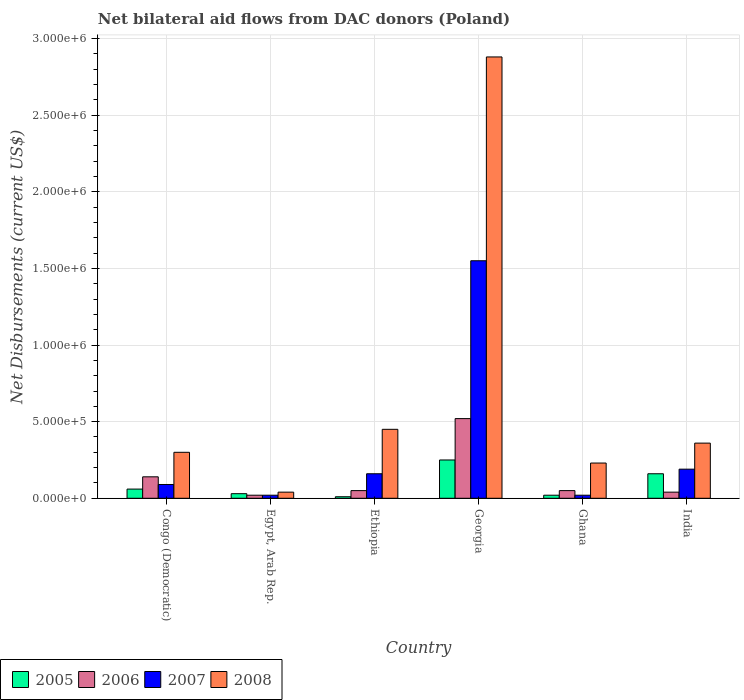How many bars are there on the 1st tick from the right?
Keep it short and to the point. 4. What is the label of the 2nd group of bars from the left?
Provide a short and direct response. Egypt, Arab Rep. In which country was the net bilateral aid flows in 2005 maximum?
Make the answer very short. Georgia. In which country was the net bilateral aid flows in 2006 minimum?
Offer a terse response. Egypt, Arab Rep. What is the total net bilateral aid flows in 2005 in the graph?
Your response must be concise. 5.30e+05. What is the difference between the net bilateral aid flows in 2005 in Ghana and that in India?
Your answer should be very brief. -1.40e+05. What is the average net bilateral aid flows in 2008 per country?
Provide a succinct answer. 7.10e+05. What is the difference between the net bilateral aid flows of/in 2006 and net bilateral aid flows of/in 2008 in Egypt, Arab Rep.?
Provide a short and direct response. -2.00e+04. In how many countries, is the net bilateral aid flows in 2008 greater than 1500000 US$?
Keep it short and to the point. 1. What is the ratio of the net bilateral aid flows in 2006 in Georgia to that in Ghana?
Your answer should be very brief. 10.4. Is the net bilateral aid flows in 2005 in Congo (Democratic) less than that in Ethiopia?
Make the answer very short. No. Is the difference between the net bilateral aid flows in 2006 in Congo (Democratic) and India greater than the difference between the net bilateral aid flows in 2008 in Congo (Democratic) and India?
Your answer should be very brief. Yes. What is the difference between the highest and the second highest net bilateral aid flows in 2007?
Keep it short and to the point. 1.39e+06. In how many countries, is the net bilateral aid flows in 2007 greater than the average net bilateral aid flows in 2007 taken over all countries?
Your response must be concise. 1. Is the sum of the net bilateral aid flows in 2007 in Egypt, Arab Rep. and Georgia greater than the maximum net bilateral aid flows in 2006 across all countries?
Keep it short and to the point. Yes. What does the 3rd bar from the right in Ghana represents?
Keep it short and to the point. 2006. How many bars are there?
Make the answer very short. 24. Are all the bars in the graph horizontal?
Your answer should be compact. No. Are the values on the major ticks of Y-axis written in scientific E-notation?
Give a very brief answer. Yes. How many legend labels are there?
Keep it short and to the point. 4. What is the title of the graph?
Your answer should be very brief. Net bilateral aid flows from DAC donors (Poland). What is the label or title of the X-axis?
Make the answer very short. Country. What is the label or title of the Y-axis?
Your answer should be compact. Net Disbursements (current US$). What is the Net Disbursements (current US$) of 2005 in Congo (Democratic)?
Ensure brevity in your answer.  6.00e+04. What is the Net Disbursements (current US$) of 2006 in Congo (Democratic)?
Your answer should be very brief. 1.40e+05. What is the Net Disbursements (current US$) in 2005 in Egypt, Arab Rep.?
Your answer should be compact. 3.00e+04. What is the Net Disbursements (current US$) of 2006 in Egypt, Arab Rep.?
Offer a terse response. 2.00e+04. What is the Net Disbursements (current US$) in 2008 in Egypt, Arab Rep.?
Ensure brevity in your answer.  4.00e+04. What is the Net Disbursements (current US$) in 2006 in Georgia?
Your answer should be compact. 5.20e+05. What is the Net Disbursements (current US$) of 2007 in Georgia?
Your response must be concise. 1.55e+06. What is the Net Disbursements (current US$) in 2008 in Georgia?
Offer a very short reply. 2.88e+06. What is the Net Disbursements (current US$) in 2007 in Ghana?
Make the answer very short. 2.00e+04. What is the Net Disbursements (current US$) of 2008 in Ghana?
Make the answer very short. 2.30e+05. What is the Net Disbursements (current US$) in 2005 in India?
Give a very brief answer. 1.60e+05. What is the Net Disbursements (current US$) in 2007 in India?
Provide a succinct answer. 1.90e+05. What is the Net Disbursements (current US$) of 2008 in India?
Provide a short and direct response. 3.60e+05. Across all countries, what is the maximum Net Disbursements (current US$) in 2005?
Make the answer very short. 2.50e+05. Across all countries, what is the maximum Net Disbursements (current US$) of 2006?
Your answer should be compact. 5.20e+05. Across all countries, what is the maximum Net Disbursements (current US$) in 2007?
Ensure brevity in your answer.  1.55e+06. Across all countries, what is the maximum Net Disbursements (current US$) in 2008?
Your answer should be very brief. 2.88e+06. Across all countries, what is the minimum Net Disbursements (current US$) in 2008?
Your response must be concise. 4.00e+04. What is the total Net Disbursements (current US$) of 2005 in the graph?
Provide a succinct answer. 5.30e+05. What is the total Net Disbursements (current US$) of 2006 in the graph?
Your answer should be very brief. 8.20e+05. What is the total Net Disbursements (current US$) of 2007 in the graph?
Your answer should be compact. 2.03e+06. What is the total Net Disbursements (current US$) of 2008 in the graph?
Make the answer very short. 4.26e+06. What is the difference between the Net Disbursements (current US$) in 2005 in Congo (Democratic) and that in Egypt, Arab Rep.?
Offer a terse response. 3.00e+04. What is the difference between the Net Disbursements (current US$) of 2007 in Congo (Democratic) and that in Ethiopia?
Offer a terse response. -7.00e+04. What is the difference between the Net Disbursements (current US$) in 2008 in Congo (Democratic) and that in Ethiopia?
Offer a very short reply. -1.50e+05. What is the difference between the Net Disbursements (current US$) of 2006 in Congo (Democratic) and that in Georgia?
Your answer should be compact. -3.80e+05. What is the difference between the Net Disbursements (current US$) of 2007 in Congo (Democratic) and that in Georgia?
Ensure brevity in your answer.  -1.46e+06. What is the difference between the Net Disbursements (current US$) in 2008 in Congo (Democratic) and that in Georgia?
Give a very brief answer. -2.58e+06. What is the difference between the Net Disbursements (current US$) in 2005 in Congo (Democratic) and that in Ghana?
Your answer should be very brief. 4.00e+04. What is the difference between the Net Disbursements (current US$) in 2006 in Congo (Democratic) and that in Ghana?
Ensure brevity in your answer.  9.00e+04. What is the difference between the Net Disbursements (current US$) in 2005 in Congo (Democratic) and that in India?
Provide a short and direct response. -1.00e+05. What is the difference between the Net Disbursements (current US$) in 2006 in Congo (Democratic) and that in India?
Your answer should be very brief. 1.00e+05. What is the difference between the Net Disbursements (current US$) of 2008 in Egypt, Arab Rep. and that in Ethiopia?
Provide a succinct answer. -4.10e+05. What is the difference between the Net Disbursements (current US$) in 2006 in Egypt, Arab Rep. and that in Georgia?
Make the answer very short. -5.00e+05. What is the difference between the Net Disbursements (current US$) of 2007 in Egypt, Arab Rep. and that in Georgia?
Your answer should be compact. -1.53e+06. What is the difference between the Net Disbursements (current US$) in 2008 in Egypt, Arab Rep. and that in Georgia?
Give a very brief answer. -2.84e+06. What is the difference between the Net Disbursements (current US$) in 2006 in Egypt, Arab Rep. and that in Ghana?
Provide a short and direct response. -3.00e+04. What is the difference between the Net Disbursements (current US$) in 2007 in Egypt, Arab Rep. and that in Ghana?
Give a very brief answer. 0. What is the difference between the Net Disbursements (current US$) in 2008 in Egypt, Arab Rep. and that in Ghana?
Offer a very short reply. -1.90e+05. What is the difference between the Net Disbursements (current US$) of 2007 in Egypt, Arab Rep. and that in India?
Your response must be concise. -1.70e+05. What is the difference between the Net Disbursements (current US$) in 2008 in Egypt, Arab Rep. and that in India?
Your answer should be very brief. -3.20e+05. What is the difference between the Net Disbursements (current US$) of 2006 in Ethiopia and that in Georgia?
Give a very brief answer. -4.70e+05. What is the difference between the Net Disbursements (current US$) in 2007 in Ethiopia and that in Georgia?
Ensure brevity in your answer.  -1.39e+06. What is the difference between the Net Disbursements (current US$) in 2008 in Ethiopia and that in Georgia?
Provide a short and direct response. -2.43e+06. What is the difference between the Net Disbursements (current US$) of 2005 in Ethiopia and that in Ghana?
Your response must be concise. -10000. What is the difference between the Net Disbursements (current US$) of 2005 in Ethiopia and that in India?
Your answer should be compact. -1.50e+05. What is the difference between the Net Disbursements (current US$) of 2006 in Ethiopia and that in India?
Offer a very short reply. 10000. What is the difference between the Net Disbursements (current US$) of 2008 in Ethiopia and that in India?
Make the answer very short. 9.00e+04. What is the difference between the Net Disbursements (current US$) of 2005 in Georgia and that in Ghana?
Provide a short and direct response. 2.30e+05. What is the difference between the Net Disbursements (current US$) of 2007 in Georgia and that in Ghana?
Provide a succinct answer. 1.53e+06. What is the difference between the Net Disbursements (current US$) of 2008 in Georgia and that in Ghana?
Give a very brief answer. 2.65e+06. What is the difference between the Net Disbursements (current US$) in 2006 in Georgia and that in India?
Keep it short and to the point. 4.80e+05. What is the difference between the Net Disbursements (current US$) in 2007 in Georgia and that in India?
Offer a terse response. 1.36e+06. What is the difference between the Net Disbursements (current US$) of 2008 in Georgia and that in India?
Give a very brief answer. 2.52e+06. What is the difference between the Net Disbursements (current US$) of 2005 in Congo (Democratic) and the Net Disbursements (current US$) of 2007 in Egypt, Arab Rep.?
Your answer should be very brief. 4.00e+04. What is the difference between the Net Disbursements (current US$) in 2005 in Congo (Democratic) and the Net Disbursements (current US$) in 2008 in Egypt, Arab Rep.?
Keep it short and to the point. 2.00e+04. What is the difference between the Net Disbursements (current US$) of 2006 in Congo (Democratic) and the Net Disbursements (current US$) of 2007 in Egypt, Arab Rep.?
Keep it short and to the point. 1.20e+05. What is the difference between the Net Disbursements (current US$) in 2006 in Congo (Democratic) and the Net Disbursements (current US$) in 2008 in Egypt, Arab Rep.?
Your answer should be compact. 1.00e+05. What is the difference between the Net Disbursements (current US$) in 2007 in Congo (Democratic) and the Net Disbursements (current US$) in 2008 in Egypt, Arab Rep.?
Your response must be concise. 5.00e+04. What is the difference between the Net Disbursements (current US$) of 2005 in Congo (Democratic) and the Net Disbursements (current US$) of 2006 in Ethiopia?
Offer a very short reply. 10000. What is the difference between the Net Disbursements (current US$) in 2005 in Congo (Democratic) and the Net Disbursements (current US$) in 2007 in Ethiopia?
Your answer should be compact. -1.00e+05. What is the difference between the Net Disbursements (current US$) of 2005 in Congo (Democratic) and the Net Disbursements (current US$) of 2008 in Ethiopia?
Your answer should be compact. -3.90e+05. What is the difference between the Net Disbursements (current US$) of 2006 in Congo (Democratic) and the Net Disbursements (current US$) of 2008 in Ethiopia?
Provide a short and direct response. -3.10e+05. What is the difference between the Net Disbursements (current US$) in 2007 in Congo (Democratic) and the Net Disbursements (current US$) in 2008 in Ethiopia?
Keep it short and to the point. -3.60e+05. What is the difference between the Net Disbursements (current US$) of 2005 in Congo (Democratic) and the Net Disbursements (current US$) of 2006 in Georgia?
Provide a short and direct response. -4.60e+05. What is the difference between the Net Disbursements (current US$) of 2005 in Congo (Democratic) and the Net Disbursements (current US$) of 2007 in Georgia?
Give a very brief answer. -1.49e+06. What is the difference between the Net Disbursements (current US$) in 2005 in Congo (Democratic) and the Net Disbursements (current US$) in 2008 in Georgia?
Provide a short and direct response. -2.82e+06. What is the difference between the Net Disbursements (current US$) in 2006 in Congo (Democratic) and the Net Disbursements (current US$) in 2007 in Georgia?
Your answer should be compact. -1.41e+06. What is the difference between the Net Disbursements (current US$) in 2006 in Congo (Democratic) and the Net Disbursements (current US$) in 2008 in Georgia?
Make the answer very short. -2.74e+06. What is the difference between the Net Disbursements (current US$) in 2007 in Congo (Democratic) and the Net Disbursements (current US$) in 2008 in Georgia?
Offer a very short reply. -2.79e+06. What is the difference between the Net Disbursements (current US$) in 2006 in Congo (Democratic) and the Net Disbursements (current US$) in 2008 in Ghana?
Keep it short and to the point. -9.00e+04. What is the difference between the Net Disbursements (current US$) in 2007 in Congo (Democratic) and the Net Disbursements (current US$) in 2008 in Ghana?
Ensure brevity in your answer.  -1.40e+05. What is the difference between the Net Disbursements (current US$) of 2005 in Congo (Democratic) and the Net Disbursements (current US$) of 2006 in India?
Provide a succinct answer. 2.00e+04. What is the difference between the Net Disbursements (current US$) in 2005 in Congo (Democratic) and the Net Disbursements (current US$) in 2008 in India?
Provide a succinct answer. -3.00e+05. What is the difference between the Net Disbursements (current US$) in 2006 in Congo (Democratic) and the Net Disbursements (current US$) in 2007 in India?
Offer a terse response. -5.00e+04. What is the difference between the Net Disbursements (current US$) of 2006 in Congo (Democratic) and the Net Disbursements (current US$) of 2008 in India?
Make the answer very short. -2.20e+05. What is the difference between the Net Disbursements (current US$) in 2005 in Egypt, Arab Rep. and the Net Disbursements (current US$) in 2008 in Ethiopia?
Ensure brevity in your answer.  -4.20e+05. What is the difference between the Net Disbursements (current US$) in 2006 in Egypt, Arab Rep. and the Net Disbursements (current US$) in 2008 in Ethiopia?
Offer a very short reply. -4.30e+05. What is the difference between the Net Disbursements (current US$) of 2007 in Egypt, Arab Rep. and the Net Disbursements (current US$) of 2008 in Ethiopia?
Provide a succinct answer. -4.30e+05. What is the difference between the Net Disbursements (current US$) in 2005 in Egypt, Arab Rep. and the Net Disbursements (current US$) in 2006 in Georgia?
Keep it short and to the point. -4.90e+05. What is the difference between the Net Disbursements (current US$) in 2005 in Egypt, Arab Rep. and the Net Disbursements (current US$) in 2007 in Georgia?
Provide a short and direct response. -1.52e+06. What is the difference between the Net Disbursements (current US$) in 2005 in Egypt, Arab Rep. and the Net Disbursements (current US$) in 2008 in Georgia?
Make the answer very short. -2.85e+06. What is the difference between the Net Disbursements (current US$) in 2006 in Egypt, Arab Rep. and the Net Disbursements (current US$) in 2007 in Georgia?
Offer a very short reply. -1.53e+06. What is the difference between the Net Disbursements (current US$) of 2006 in Egypt, Arab Rep. and the Net Disbursements (current US$) of 2008 in Georgia?
Offer a terse response. -2.86e+06. What is the difference between the Net Disbursements (current US$) in 2007 in Egypt, Arab Rep. and the Net Disbursements (current US$) in 2008 in Georgia?
Ensure brevity in your answer.  -2.86e+06. What is the difference between the Net Disbursements (current US$) of 2005 in Egypt, Arab Rep. and the Net Disbursements (current US$) of 2006 in Ghana?
Give a very brief answer. -2.00e+04. What is the difference between the Net Disbursements (current US$) in 2006 in Egypt, Arab Rep. and the Net Disbursements (current US$) in 2008 in Ghana?
Offer a terse response. -2.10e+05. What is the difference between the Net Disbursements (current US$) in 2005 in Egypt, Arab Rep. and the Net Disbursements (current US$) in 2006 in India?
Offer a very short reply. -10000. What is the difference between the Net Disbursements (current US$) in 2005 in Egypt, Arab Rep. and the Net Disbursements (current US$) in 2008 in India?
Your response must be concise. -3.30e+05. What is the difference between the Net Disbursements (current US$) in 2006 in Egypt, Arab Rep. and the Net Disbursements (current US$) in 2007 in India?
Keep it short and to the point. -1.70e+05. What is the difference between the Net Disbursements (current US$) of 2006 in Egypt, Arab Rep. and the Net Disbursements (current US$) of 2008 in India?
Provide a short and direct response. -3.40e+05. What is the difference between the Net Disbursements (current US$) of 2007 in Egypt, Arab Rep. and the Net Disbursements (current US$) of 2008 in India?
Keep it short and to the point. -3.40e+05. What is the difference between the Net Disbursements (current US$) in 2005 in Ethiopia and the Net Disbursements (current US$) in 2006 in Georgia?
Your response must be concise. -5.10e+05. What is the difference between the Net Disbursements (current US$) of 2005 in Ethiopia and the Net Disbursements (current US$) of 2007 in Georgia?
Your answer should be very brief. -1.54e+06. What is the difference between the Net Disbursements (current US$) in 2005 in Ethiopia and the Net Disbursements (current US$) in 2008 in Georgia?
Your response must be concise. -2.87e+06. What is the difference between the Net Disbursements (current US$) in 2006 in Ethiopia and the Net Disbursements (current US$) in 2007 in Georgia?
Offer a terse response. -1.50e+06. What is the difference between the Net Disbursements (current US$) in 2006 in Ethiopia and the Net Disbursements (current US$) in 2008 in Georgia?
Provide a succinct answer. -2.83e+06. What is the difference between the Net Disbursements (current US$) of 2007 in Ethiopia and the Net Disbursements (current US$) of 2008 in Georgia?
Make the answer very short. -2.72e+06. What is the difference between the Net Disbursements (current US$) in 2005 in Ethiopia and the Net Disbursements (current US$) in 2008 in Ghana?
Offer a terse response. -2.20e+05. What is the difference between the Net Disbursements (current US$) in 2006 in Ethiopia and the Net Disbursements (current US$) in 2007 in Ghana?
Give a very brief answer. 3.00e+04. What is the difference between the Net Disbursements (current US$) of 2006 in Ethiopia and the Net Disbursements (current US$) of 2008 in Ghana?
Offer a terse response. -1.80e+05. What is the difference between the Net Disbursements (current US$) of 2007 in Ethiopia and the Net Disbursements (current US$) of 2008 in Ghana?
Your answer should be compact. -7.00e+04. What is the difference between the Net Disbursements (current US$) in 2005 in Ethiopia and the Net Disbursements (current US$) in 2006 in India?
Your answer should be very brief. -3.00e+04. What is the difference between the Net Disbursements (current US$) in 2005 in Ethiopia and the Net Disbursements (current US$) in 2008 in India?
Keep it short and to the point. -3.50e+05. What is the difference between the Net Disbursements (current US$) of 2006 in Ethiopia and the Net Disbursements (current US$) of 2008 in India?
Your response must be concise. -3.10e+05. What is the difference between the Net Disbursements (current US$) of 2005 in Georgia and the Net Disbursements (current US$) of 2007 in Ghana?
Your response must be concise. 2.30e+05. What is the difference between the Net Disbursements (current US$) of 2006 in Georgia and the Net Disbursements (current US$) of 2007 in Ghana?
Your response must be concise. 5.00e+05. What is the difference between the Net Disbursements (current US$) of 2006 in Georgia and the Net Disbursements (current US$) of 2008 in Ghana?
Your answer should be very brief. 2.90e+05. What is the difference between the Net Disbursements (current US$) in 2007 in Georgia and the Net Disbursements (current US$) in 2008 in Ghana?
Provide a short and direct response. 1.32e+06. What is the difference between the Net Disbursements (current US$) of 2005 in Georgia and the Net Disbursements (current US$) of 2006 in India?
Keep it short and to the point. 2.10e+05. What is the difference between the Net Disbursements (current US$) of 2005 in Georgia and the Net Disbursements (current US$) of 2007 in India?
Your response must be concise. 6.00e+04. What is the difference between the Net Disbursements (current US$) of 2006 in Georgia and the Net Disbursements (current US$) of 2008 in India?
Your answer should be compact. 1.60e+05. What is the difference between the Net Disbursements (current US$) of 2007 in Georgia and the Net Disbursements (current US$) of 2008 in India?
Provide a short and direct response. 1.19e+06. What is the difference between the Net Disbursements (current US$) of 2005 in Ghana and the Net Disbursements (current US$) of 2006 in India?
Provide a succinct answer. -2.00e+04. What is the difference between the Net Disbursements (current US$) of 2005 in Ghana and the Net Disbursements (current US$) of 2007 in India?
Offer a terse response. -1.70e+05. What is the difference between the Net Disbursements (current US$) in 2006 in Ghana and the Net Disbursements (current US$) in 2007 in India?
Provide a succinct answer. -1.40e+05. What is the difference between the Net Disbursements (current US$) in 2006 in Ghana and the Net Disbursements (current US$) in 2008 in India?
Your answer should be very brief. -3.10e+05. What is the average Net Disbursements (current US$) in 2005 per country?
Make the answer very short. 8.83e+04. What is the average Net Disbursements (current US$) of 2006 per country?
Keep it short and to the point. 1.37e+05. What is the average Net Disbursements (current US$) in 2007 per country?
Your response must be concise. 3.38e+05. What is the average Net Disbursements (current US$) in 2008 per country?
Offer a terse response. 7.10e+05. What is the difference between the Net Disbursements (current US$) of 2005 and Net Disbursements (current US$) of 2006 in Congo (Democratic)?
Your answer should be very brief. -8.00e+04. What is the difference between the Net Disbursements (current US$) in 2005 and Net Disbursements (current US$) in 2007 in Congo (Democratic)?
Make the answer very short. -3.00e+04. What is the difference between the Net Disbursements (current US$) in 2006 and Net Disbursements (current US$) in 2007 in Congo (Democratic)?
Your answer should be compact. 5.00e+04. What is the difference between the Net Disbursements (current US$) in 2005 and Net Disbursements (current US$) in 2007 in Egypt, Arab Rep.?
Keep it short and to the point. 10000. What is the difference between the Net Disbursements (current US$) in 2007 and Net Disbursements (current US$) in 2008 in Egypt, Arab Rep.?
Your response must be concise. -2.00e+04. What is the difference between the Net Disbursements (current US$) of 2005 and Net Disbursements (current US$) of 2006 in Ethiopia?
Provide a short and direct response. -4.00e+04. What is the difference between the Net Disbursements (current US$) of 2005 and Net Disbursements (current US$) of 2007 in Ethiopia?
Offer a terse response. -1.50e+05. What is the difference between the Net Disbursements (current US$) in 2005 and Net Disbursements (current US$) in 2008 in Ethiopia?
Keep it short and to the point. -4.40e+05. What is the difference between the Net Disbursements (current US$) in 2006 and Net Disbursements (current US$) in 2007 in Ethiopia?
Provide a succinct answer. -1.10e+05. What is the difference between the Net Disbursements (current US$) of 2006 and Net Disbursements (current US$) of 2008 in Ethiopia?
Provide a short and direct response. -4.00e+05. What is the difference between the Net Disbursements (current US$) of 2005 and Net Disbursements (current US$) of 2007 in Georgia?
Offer a very short reply. -1.30e+06. What is the difference between the Net Disbursements (current US$) in 2005 and Net Disbursements (current US$) in 2008 in Georgia?
Make the answer very short. -2.63e+06. What is the difference between the Net Disbursements (current US$) in 2006 and Net Disbursements (current US$) in 2007 in Georgia?
Ensure brevity in your answer.  -1.03e+06. What is the difference between the Net Disbursements (current US$) of 2006 and Net Disbursements (current US$) of 2008 in Georgia?
Your answer should be compact. -2.36e+06. What is the difference between the Net Disbursements (current US$) of 2007 and Net Disbursements (current US$) of 2008 in Georgia?
Your answer should be very brief. -1.33e+06. What is the difference between the Net Disbursements (current US$) in 2005 and Net Disbursements (current US$) in 2008 in Ghana?
Provide a short and direct response. -2.10e+05. What is the difference between the Net Disbursements (current US$) in 2007 and Net Disbursements (current US$) in 2008 in Ghana?
Offer a terse response. -2.10e+05. What is the difference between the Net Disbursements (current US$) in 2005 and Net Disbursements (current US$) in 2006 in India?
Provide a short and direct response. 1.20e+05. What is the difference between the Net Disbursements (current US$) of 2006 and Net Disbursements (current US$) of 2008 in India?
Provide a succinct answer. -3.20e+05. What is the ratio of the Net Disbursements (current US$) of 2005 in Congo (Democratic) to that in Ethiopia?
Give a very brief answer. 6. What is the ratio of the Net Disbursements (current US$) of 2007 in Congo (Democratic) to that in Ethiopia?
Offer a very short reply. 0.56. What is the ratio of the Net Disbursements (current US$) in 2005 in Congo (Democratic) to that in Georgia?
Give a very brief answer. 0.24. What is the ratio of the Net Disbursements (current US$) in 2006 in Congo (Democratic) to that in Georgia?
Offer a terse response. 0.27. What is the ratio of the Net Disbursements (current US$) in 2007 in Congo (Democratic) to that in Georgia?
Your response must be concise. 0.06. What is the ratio of the Net Disbursements (current US$) in 2008 in Congo (Democratic) to that in Georgia?
Your answer should be very brief. 0.1. What is the ratio of the Net Disbursements (current US$) of 2007 in Congo (Democratic) to that in Ghana?
Offer a terse response. 4.5. What is the ratio of the Net Disbursements (current US$) of 2008 in Congo (Democratic) to that in Ghana?
Ensure brevity in your answer.  1.3. What is the ratio of the Net Disbursements (current US$) of 2005 in Congo (Democratic) to that in India?
Keep it short and to the point. 0.38. What is the ratio of the Net Disbursements (current US$) in 2006 in Congo (Democratic) to that in India?
Give a very brief answer. 3.5. What is the ratio of the Net Disbursements (current US$) of 2007 in Congo (Democratic) to that in India?
Your response must be concise. 0.47. What is the ratio of the Net Disbursements (current US$) in 2005 in Egypt, Arab Rep. to that in Ethiopia?
Make the answer very short. 3. What is the ratio of the Net Disbursements (current US$) of 2007 in Egypt, Arab Rep. to that in Ethiopia?
Give a very brief answer. 0.12. What is the ratio of the Net Disbursements (current US$) in 2008 in Egypt, Arab Rep. to that in Ethiopia?
Keep it short and to the point. 0.09. What is the ratio of the Net Disbursements (current US$) of 2005 in Egypt, Arab Rep. to that in Georgia?
Make the answer very short. 0.12. What is the ratio of the Net Disbursements (current US$) of 2006 in Egypt, Arab Rep. to that in Georgia?
Your answer should be very brief. 0.04. What is the ratio of the Net Disbursements (current US$) in 2007 in Egypt, Arab Rep. to that in Georgia?
Make the answer very short. 0.01. What is the ratio of the Net Disbursements (current US$) of 2008 in Egypt, Arab Rep. to that in Georgia?
Offer a terse response. 0.01. What is the ratio of the Net Disbursements (current US$) in 2005 in Egypt, Arab Rep. to that in Ghana?
Offer a very short reply. 1.5. What is the ratio of the Net Disbursements (current US$) of 2007 in Egypt, Arab Rep. to that in Ghana?
Your answer should be compact. 1. What is the ratio of the Net Disbursements (current US$) of 2008 in Egypt, Arab Rep. to that in Ghana?
Your response must be concise. 0.17. What is the ratio of the Net Disbursements (current US$) of 2005 in Egypt, Arab Rep. to that in India?
Your answer should be very brief. 0.19. What is the ratio of the Net Disbursements (current US$) in 2006 in Egypt, Arab Rep. to that in India?
Your response must be concise. 0.5. What is the ratio of the Net Disbursements (current US$) in 2007 in Egypt, Arab Rep. to that in India?
Offer a terse response. 0.11. What is the ratio of the Net Disbursements (current US$) in 2008 in Egypt, Arab Rep. to that in India?
Your response must be concise. 0.11. What is the ratio of the Net Disbursements (current US$) in 2005 in Ethiopia to that in Georgia?
Ensure brevity in your answer.  0.04. What is the ratio of the Net Disbursements (current US$) in 2006 in Ethiopia to that in Georgia?
Your response must be concise. 0.1. What is the ratio of the Net Disbursements (current US$) in 2007 in Ethiopia to that in Georgia?
Your answer should be very brief. 0.1. What is the ratio of the Net Disbursements (current US$) of 2008 in Ethiopia to that in Georgia?
Your response must be concise. 0.16. What is the ratio of the Net Disbursements (current US$) in 2005 in Ethiopia to that in Ghana?
Offer a terse response. 0.5. What is the ratio of the Net Disbursements (current US$) of 2007 in Ethiopia to that in Ghana?
Ensure brevity in your answer.  8. What is the ratio of the Net Disbursements (current US$) of 2008 in Ethiopia to that in Ghana?
Provide a succinct answer. 1.96. What is the ratio of the Net Disbursements (current US$) of 2005 in Ethiopia to that in India?
Offer a very short reply. 0.06. What is the ratio of the Net Disbursements (current US$) in 2006 in Ethiopia to that in India?
Make the answer very short. 1.25. What is the ratio of the Net Disbursements (current US$) in 2007 in Ethiopia to that in India?
Provide a short and direct response. 0.84. What is the ratio of the Net Disbursements (current US$) of 2008 in Ethiopia to that in India?
Provide a succinct answer. 1.25. What is the ratio of the Net Disbursements (current US$) in 2006 in Georgia to that in Ghana?
Your answer should be very brief. 10.4. What is the ratio of the Net Disbursements (current US$) in 2007 in Georgia to that in Ghana?
Ensure brevity in your answer.  77.5. What is the ratio of the Net Disbursements (current US$) of 2008 in Georgia to that in Ghana?
Ensure brevity in your answer.  12.52. What is the ratio of the Net Disbursements (current US$) of 2005 in Georgia to that in India?
Give a very brief answer. 1.56. What is the ratio of the Net Disbursements (current US$) in 2007 in Georgia to that in India?
Provide a succinct answer. 8.16. What is the ratio of the Net Disbursements (current US$) of 2008 in Georgia to that in India?
Your answer should be compact. 8. What is the ratio of the Net Disbursements (current US$) in 2006 in Ghana to that in India?
Your response must be concise. 1.25. What is the ratio of the Net Disbursements (current US$) of 2007 in Ghana to that in India?
Your answer should be very brief. 0.11. What is the ratio of the Net Disbursements (current US$) in 2008 in Ghana to that in India?
Give a very brief answer. 0.64. What is the difference between the highest and the second highest Net Disbursements (current US$) in 2005?
Offer a very short reply. 9.00e+04. What is the difference between the highest and the second highest Net Disbursements (current US$) in 2007?
Your answer should be compact. 1.36e+06. What is the difference between the highest and the second highest Net Disbursements (current US$) in 2008?
Your answer should be compact. 2.43e+06. What is the difference between the highest and the lowest Net Disbursements (current US$) in 2005?
Offer a terse response. 2.40e+05. What is the difference between the highest and the lowest Net Disbursements (current US$) in 2006?
Provide a succinct answer. 5.00e+05. What is the difference between the highest and the lowest Net Disbursements (current US$) of 2007?
Make the answer very short. 1.53e+06. What is the difference between the highest and the lowest Net Disbursements (current US$) of 2008?
Make the answer very short. 2.84e+06. 